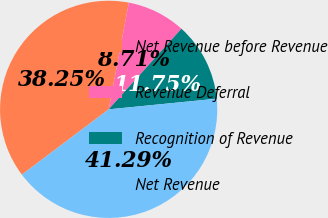<chart> <loc_0><loc_0><loc_500><loc_500><pie_chart><fcel>Net Revenue before Revenue<fcel>Revenue Deferral<fcel>Recognition of Revenue<fcel>Net Revenue<nl><fcel>38.25%<fcel>8.71%<fcel>11.75%<fcel>41.29%<nl></chart> 